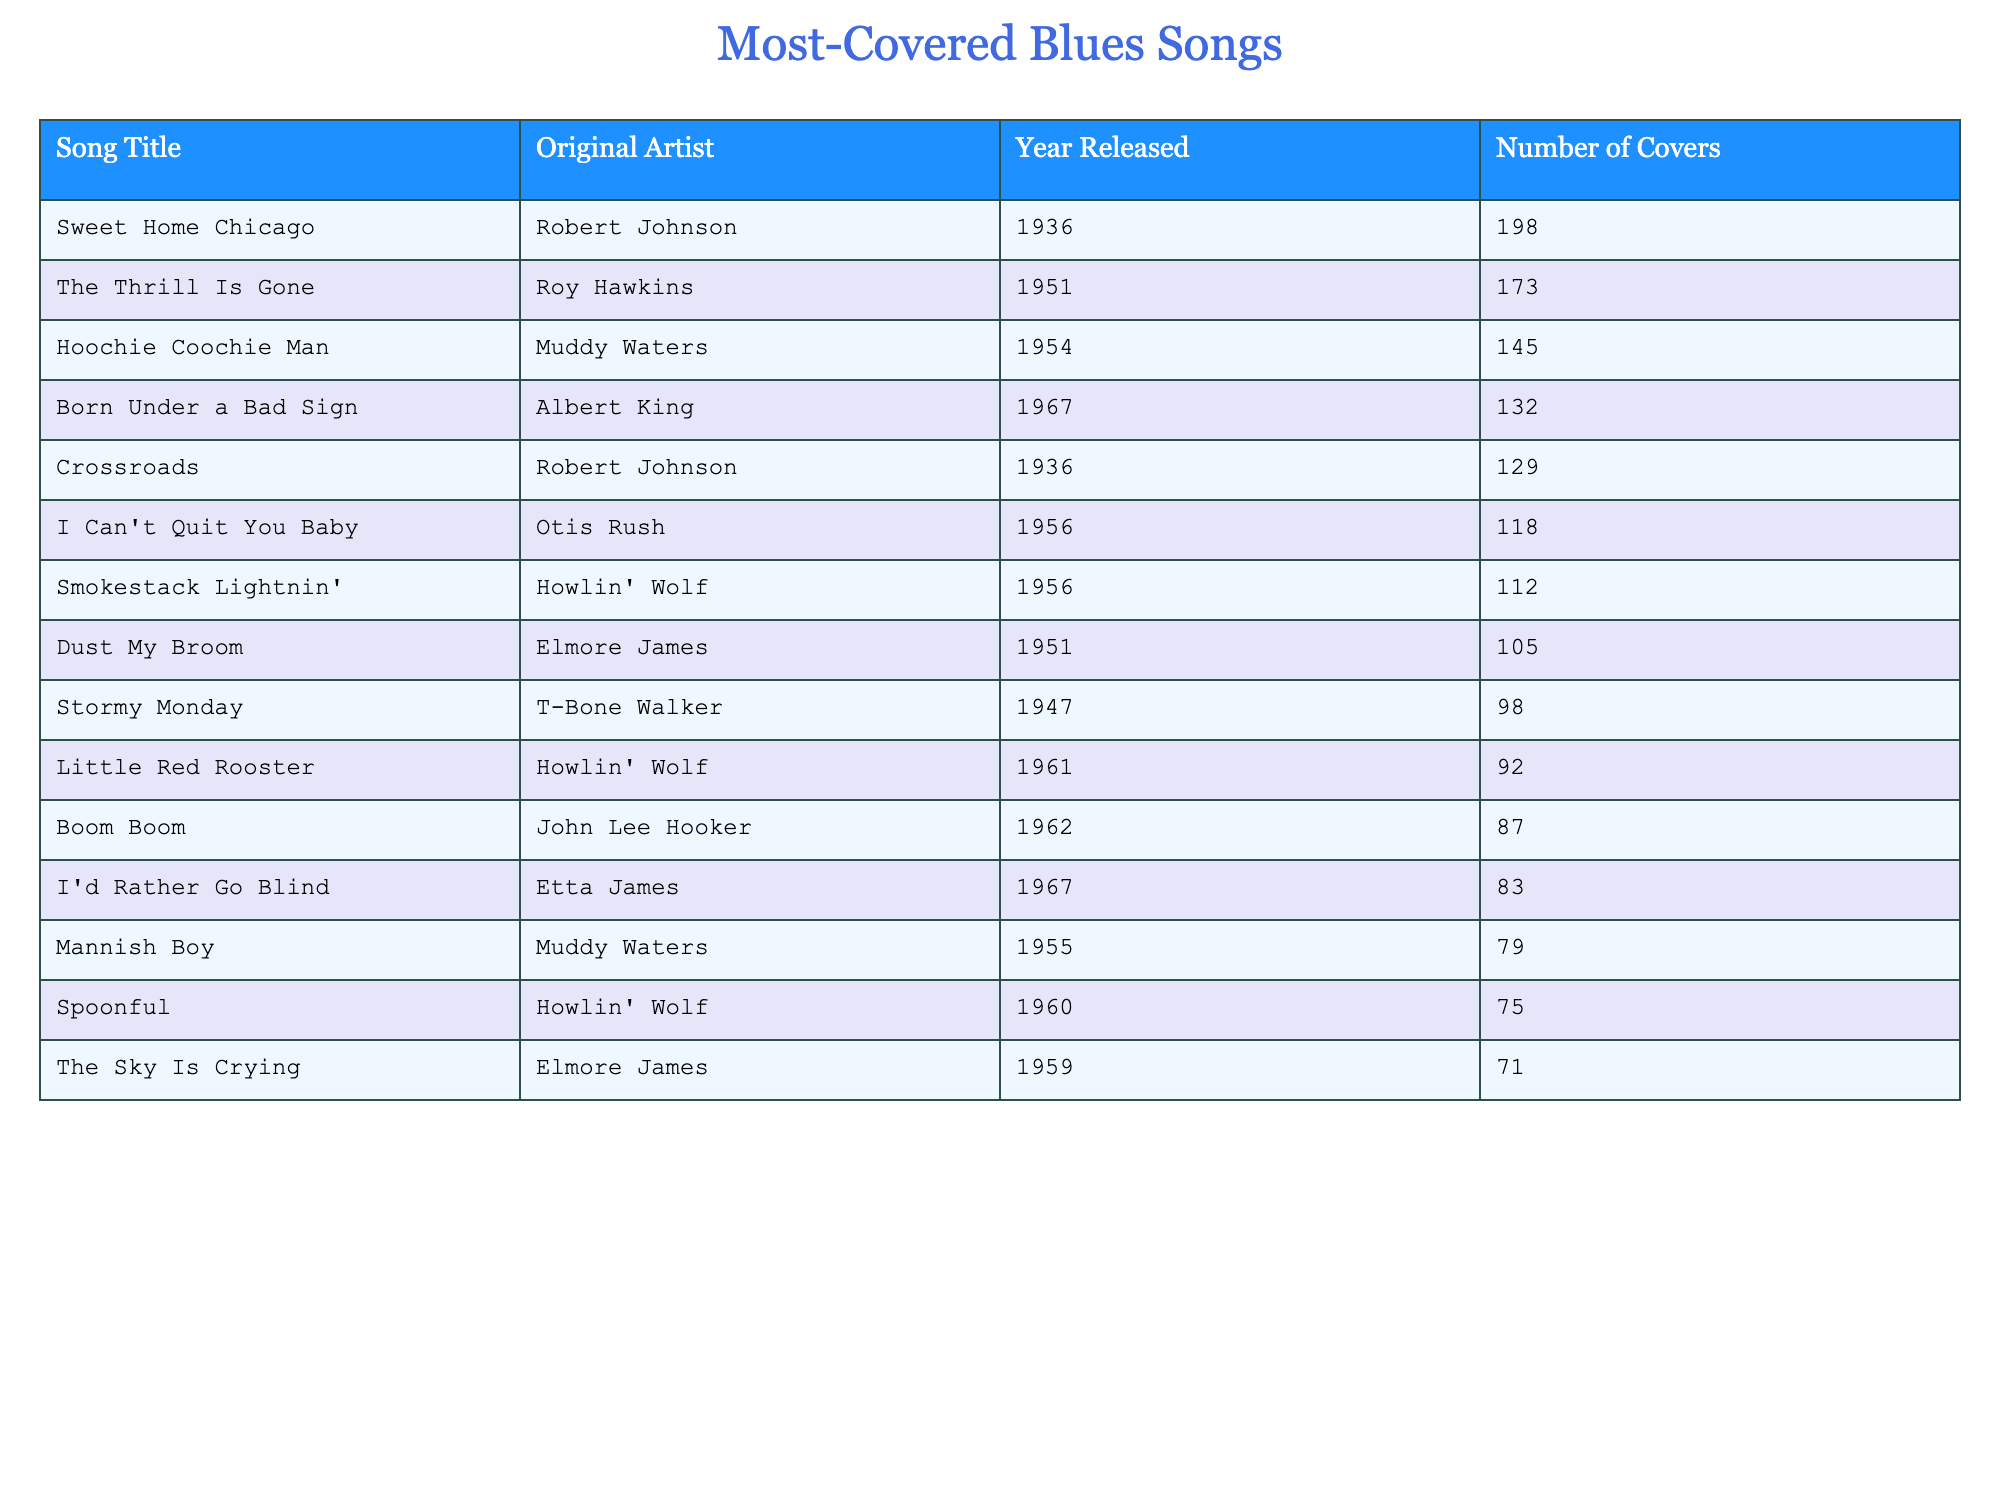What is the most covered blues song? The table shows the song "Sweet Home Chicago" by Robert Johnson, which has 198 covers listed as the highest number.
Answer: Sweet Home Chicago Which original artist has the highest number of covered songs? Robert Johnson's song "Sweet Home Chicago" has the highest covers, making him the artist with the most covers at 198.
Answer: Robert Johnson How many covers does "The Thrill Is Gone" have? The table states that "The Thrill Is Gone" has 173 covers, so you can directly refer to that number.
Answer: 173 What is the difference in the number of covers between "Hoochie Coochie Man" and "Born Under a Bad Sign"? "Hoochie Coochie Man" has 145 covers, and "Born Under a Bad Sign" has 132. The difference is 145 - 132 = 13.
Answer: 13 How many songs were originally released before 1950? The songs "Sweet Home Chicago," "The Thrill Is Gone," "Hoochie Coochie Man," "Dust My Broom," and "Stormy Monday" were released before 1950, totaling 5 songs.
Answer: 5 Which song has the least number of covers? The table indicates that "Spoonful" has the least number of covers with 75 actions.
Answer: Spoonful What is the average number of covers for the songs originally released in the 1960s? The songs from the 1960s are "Little Red Rooster" (92), "Boom Boom" (87), "I'd Rather Go Blind" (83). Their sum is 92 + 87 + 83 = 262 and the average is 262/3 = 87.33.
Answer: 87.33 Is "I Can't Quit You Baby" covered more than "Mannish Boy"? "I Can't Quit You Baby" has 118 covers while "Mannish Boy" has 79 covers, confirming that "I Can't Quit You Baby" is covered more.
Answer: Yes Which two songs have a combined total of covers above 200? "Sweet Home Chicago" (198) and "The Thrill Is Gone" (173) combine for 371, surpassing 200.
Answer: Yes Which original artist had two songs in the table? Howlin' Wolf has two songs listed: "Smokestack Lightnin'" and "Little Red Rooster."
Answer: Howlin' Wolf 